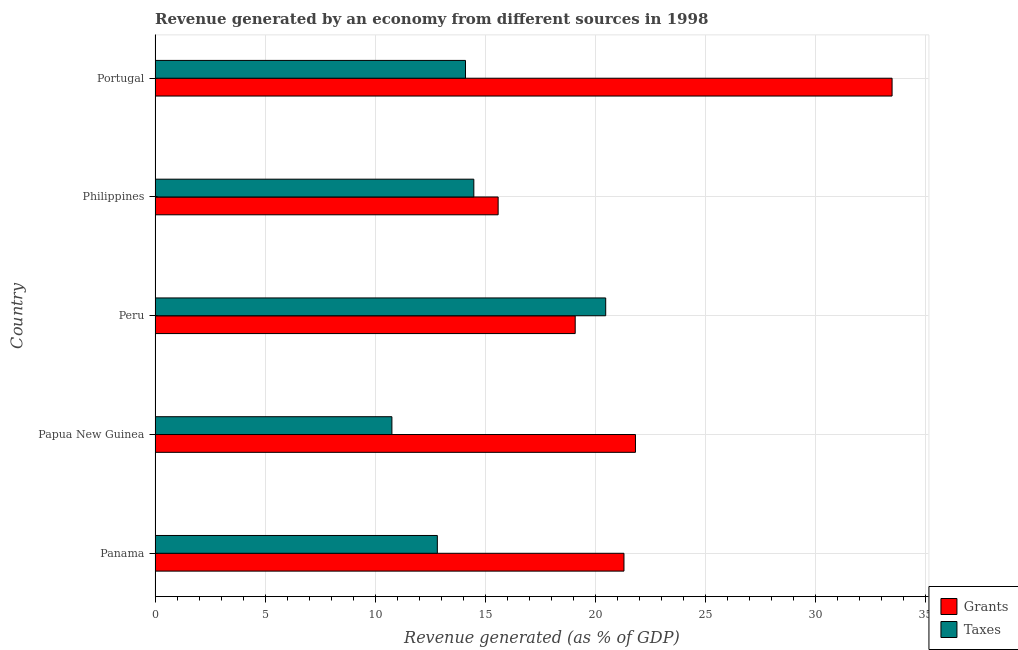How many groups of bars are there?
Ensure brevity in your answer.  5. Are the number of bars per tick equal to the number of legend labels?
Provide a short and direct response. Yes. What is the label of the 4th group of bars from the top?
Your response must be concise. Papua New Guinea. What is the revenue generated by grants in Portugal?
Ensure brevity in your answer.  33.5. Across all countries, what is the maximum revenue generated by grants?
Offer a terse response. 33.5. Across all countries, what is the minimum revenue generated by grants?
Your answer should be very brief. 15.59. In which country was the revenue generated by taxes minimum?
Your response must be concise. Papua New Guinea. What is the total revenue generated by taxes in the graph?
Offer a terse response. 72.67. What is the difference between the revenue generated by grants in Panama and that in Portugal?
Make the answer very short. -12.18. What is the difference between the revenue generated by taxes in Papua New Guinea and the revenue generated by grants in Portugal?
Offer a very short reply. -22.73. What is the average revenue generated by grants per country?
Provide a short and direct response. 22.27. What is the difference between the revenue generated by taxes and revenue generated by grants in Peru?
Your answer should be compact. 1.39. In how many countries, is the revenue generated by taxes greater than 1 %?
Your answer should be very brief. 5. What is the ratio of the revenue generated by taxes in Panama to that in Portugal?
Offer a terse response. 0.91. What is the difference between the highest and the second highest revenue generated by taxes?
Provide a short and direct response. 5.99. What is the difference between the highest and the lowest revenue generated by taxes?
Keep it short and to the point. 9.72. Is the sum of the revenue generated by taxes in Panama and Philippines greater than the maximum revenue generated by grants across all countries?
Provide a short and direct response. No. What does the 1st bar from the top in Philippines represents?
Provide a short and direct response. Taxes. What does the 2nd bar from the bottom in Peru represents?
Provide a short and direct response. Taxes. How many bars are there?
Offer a terse response. 10. How many countries are there in the graph?
Provide a short and direct response. 5. Does the graph contain any zero values?
Provide a succinct answer. No. Where does the legend appear in the graph?
Your answer should be very brief. Bottom right. How are the legend labels stacked?
Keep it short and to the point. Vertical. What is the title of the graph?
Offer a terse response. Revenue generated by an economy from different sources in 1998. Does "Overweight" appear as one of the legend labels in the graph?
Keep it short and to the point. No. What is the label or title of the X-axis?
Ensure brevity in your answer.  Revenue generated (as % of GDP). What is the Revenue generated (as % of GDP) of Grants in Panama?
Your response must be concise. 21.31. What is the Revenue generated (as % of GDP) in Taxes in Panama?
Offer a very short reply. 12.83. What is the Revenue generated (as % of GDP) of Grants in Papua New Guinea?
Offer a very short reply. 21.83. What is the Revenue generated (as % of GDP) in Taxes in Papua New Guinea?
Give a very brief answer. 10.76. What is the Revenue generated (as % of GDP) in Grants in Peru?
Give a very brief answer. 19.09. What is the Revenue generated (as % of GDP) of Taxes in Peru?
Provide a succinct answer. 20.48. What is the Revenue generated (as % of GDP) in Grants in Philippines?
Keep it short and to the point. 15.59. What is the Revenue generated (as % of GDP) in Taxes in Philippines?
Keep it short and to the point. 14.49. What is the Revenue generated (as % of GDP) of Grants in Portugal?
Offer a very short reply. 33.5. What is the Revenue generated (as % of GDP) in Taxes in Portugal?
Ensure brevity in your answer.  14.11. Across all countries, what is the maximum Revenue generated (as % of GDP) of Grants?
Provide a short and direct response. 33.5. Across all countries, what is the maximum Revenue generated (as % of GDP) in Taxes?
Give a very brief answer. 20.48. Across all countries, what is the minimum Revenue generated (as % of GDP) in Grants?
Your answer should be very brief. 15.59. Across all countries, what is the minimum Revenue generated (as % of GDP) of Taxes?
Offer a terse response. 10.76. What is the total Revenue generated (as % of GDP) in Grants in the graph?
Provide a succinct answer. 111.33. What is the total Revenue generated (as % of GDP) of Taxes in the graph?
Offer a terse response. 72.67. What is the difference between the Revenue generated (as % of GDP) in Grants in Panama and that in Papua New Guinea?
Your answer should be very brief. -0.52. What is the difference between the Revenue generated (as % of GDP) of Taxes in Panama and that in Papua New Guinea?
Provide a succinct answer. 2.06. What is the difference between the Revenue generated (as % of GDP) of Grants in Panama and that in Peru?
Offer a terse response. 2.22. What is the difference between the Revenue generated (as % of GDP) of Taxes in Panama and that in Peru?
Make the answer very short. -7.65. What is the difference between the Revenue generated (as % of GDP) of Grants in Panama and that in Philippines?
Offer a terse response. 5.72. What is the difference between the Revenue generated (as % of GDP) of Taxes in Panama and that in Philippines?
Offer a very short reply. -1.66. What is the difference between the Revenue generated (as % of GDP) in Grants in Panama and that in Portugal?
Keep it short and to the point. -12.18. What is the difference between the Revenue generated (as % of GDP) in Taxes in Panama and that in Portugal?
Your response must be concise. -1.28. What is the difference between the Revenue generated (as % of GDP) in Grants in Papua New Guinea and that in Peru?
Your answer should be compact. 2.74. What is the difference between the Revenue generated (as % of GDP) in Taxes in Papua New Guinea and that in Peru?
Your answer should be very brief. -9.72. What is the difference between the Revenue generated (as % of GDP) in Grants in Papua New Guinea and that in Philippines?
Give a very brief answer. 6.24. What is the difference between the Revenue generated (as % of GDP) in Taxes in Papua New Guinea and that in Philippines?
Give a very brief answer. -3.72. What is the difference between the Revenue generated (as % of GDP) of Grants in Papua New Guinea and that in Portugal?
Provide a succinct answer. -11.66. What is the difference between the Revenue generated (as % of GDP) in Taxes in Papua New Guinea and that in Portugal?
Give a very brief answer. -3.34. What is the difference between the Revenue generated (as % of GDP) in Grants in Peru and that in Philippines?
Offer a very short reply. 3.5. What is the difference between the Revenue generated (as % of GDP) of Taxes in Peru and that in Philippines?
Provide a short and direct response. 5.99. What is the difference between the Revenue generated (as % of GDP) of Grants in Peru and that in Portugal?
Offer a very short reply. -14.4. What is the difference between the Revenue generated (as % of GDP) in Taxes in Peru and that in Portugal?
Your response must be concise. 6.37. What is the difference between the Revenue generated (as % of GDP) of Grants in Philippines and that in Portugal?
Provide a short and direct response. -17.9. What is the difference between the Revenue generated (as % of GDP) in Taxes in Philippines and that in Portugal?
Provide a succinct answer. 0.38. What is the difference between the Revenue generated (as % of GDP) of Grants in Panama and the Revenue generated (as % of GDP) of Taxes in Papua New Guinea?
Offer a terse response. 10.55. What is the difference between the Revenue generated (as % of GDP) of Grants in Panama and the Revenue generated (as % of GDP) of Taxes in Peru?
Your response must be concise. 0.83. What is the difference between the Revenue generated (as % of GDP) in Grants in Panama and the Revenue generated (as % of GDP) in Taxes in Philippines?
Your answer should be very brief. 6.82. What is the difference between the Revenue generated (as % of GDP) of Grants in Panama and the Revenue generated (as % of GDP) of Taxes in Portugal?
Offer a terse response. 7.2. What is the difference between the Revenue generated (as % of GDP) of Grants in Papua New Guinea and the Revenue generated (as % of GDP) of Taxes in Peru?
Your response must be concise. 1.35. What is the difference between the Revenue generated (as % of GDP) of Grants in Papua New Guinea and the Revenue generated (as % of GDP) of Taxes in Philippines?
Keep it short and to the point. 7.35. What is the difference between the Revenue generated (as % of GDP) of Grants in Papua New Guinea and the Revenue generated (as % of GDP) of Taxes in Portugal?
Ensure brevity in your answer.  7.73. What is the difference between the Revenue generated (as % of GDP) in Grants in Peru and the Revenue generated (as % of GDP) in Taxes in Philippines?
Give a very brief answer. 4.61. What is the difference between the Revenue generated (as % of GDP) of Grants in Peru and the Revenue generated (as % of GDP) of Taxes in Portugal?
Provide a short and direct response. 4.99. What is the difference between the Revenue generated (as % of GDP) of Grants in Philippines and the Revenue generated (as % of GDP) of Taxes in Portugal?
Offer a very short reply. 1.48. What is the average Revenue generated (as % of GDP) in Grants per country?
Offer a very short reply. 22.27. What is the average Revenue generated (as % of GDP) in Taxes per country?
Offer a terse response. 14.53. What is the difference between the Revenue generated (as % of GDP) in Grants and Revenue generated (as % of GDP) in Taxes in Panama?
Provide a succinct answer. 8.48. What is the difference between the Revenue generated (as % of GDP) in Grants and Revenue generated (as % of GDP) in Taxes in Papua New Guinea?
Provide a succinct answer. 11.07. What is the difference between the Revenue generated (as % of GDP) in Grants and Revenue generated (as % of GDP) in Taxes in Peru?
Provide a short and direct response. -1.39. What is the difference between the Revenue generated (as % of GDP) in Grants and Revenue generated (as % of GDP) in Taxes in Philippines?
Give a very brief answer. 1.1. What is the difference between the Revenue generated (as % of GDP) of Grants and Revenue generated (as % of GDP) of Taxes in Portugal?
Offer a terse response. 19.39. What is the ratio of the Revenue generated (as % of GDP) of Grants in Panama to that in Papua New Guinea?
Your answer should be very brief. 0.98. What is the ratio of the Revenue generated (as % of GDP) in Taxes in Panama to that in Papua New Guinea?
Provide a succinct answer. 1.19. What is the ratio of the Revenue generated (as % of GDP) of Grants in Panama to that in Peru?
Your response must be concise. 1.12. What is the ratio of the Revenue generated (as % of GDP) of Taxes in Panama to that in Peru?
Give a very brief answer. 0.63. What is the ratio of the Revenue generated (as % of GDP) in Grants in Panama to that in Philippines?
Your answer should be very brief. 1.37. What is the ratio of the Revenue generated (as % of GDP) in Taxes in Panama to that in Philippines?
Your response must be concise. 0.89. What is the ratio of the Revenue generated (as % of GDP) of Grants in Panama to that in Portugal?
Give a very brief answer. 0.64. What is the ratio of the Revenue generated (as % of GDP) in Taxes in Panama to that in Portugal?
Keep it short and to the point. 0.91. What is the ratio of the Revenue generated (as % of GDP) in Grants in Papua New Guinea to that in Peru?
Offer a very short reply. 1.14. What is the ratio of the Revenue generated (as % of GDP) in Taxes in Papua New Guinea to that in Peru?
Your answer should be compact. 0.53. What is the ratio of the Revenue generated (as % of GDP) of Grants in Papua New Guinea to that in Philippines?
Your answer should be very brief. 1.4. What is the ratio of the Revenue generated (as % of GDP) of Taxes in Papua New Guinea to that in Philippines?
Your response must be concise. 0.74. What is the ratio of the Revenue generated (as % of GDP) in Grants in Papua New Guinea to that in Portugal?
Provide a short and direct response. 0.65. What is the ratio of the Revenue generated (as % of GDP) of Taxes in Papua New Guinea to that in Portugal?
Offer a very short reply. 0.76. What is the ratio of the Revenue generated (as % of GDP) of Grants in Peru to that in Philippines?
Ensure brevity in your answer.  1.22. What is the ratio of the Revenue generated (as % of GDP) in Taxes in Peru to that in Philippines?
Your answer should be very brief. 1.41. What is the ratio of the Revenue generated (as % of GDP) of Grants in Peru to that in Portugal?
Give a very brief answer. 0.57. What is the ratio of the Revenue generated (as % of GDP) in Taxes in Peru to that in Portugal?
Keep it short and to the point. 1.45. What is the ratio of the Revenue generated (as % of GDP) of Grants in Philippines to that in Portugal?
Ensure brevity in your answer.  0.47. What is the ratio of the Revenue generated (as % of GDP) in Taxes in Philippines to that in Portugal?
Give a very brief answer. 1.03. What is the difference between the highest and the second highest Revenue generated (as % of GDP) of Grants?
Offer a terse response. 11.66. What is the difference between the highest and the second highest Revenue generated (as % of GDP) of Taxes?
Ensure brevity in your answer.  5.99. What is the difference between the highest and the lowest Revenue generated (as % of GDP) in Grants?
Give a very brief answer. 17.9. What is the difference between the highest and the lowest Revenue generated (as % of GDP) of Taxes?
Offer a very short reply. 9.72. 